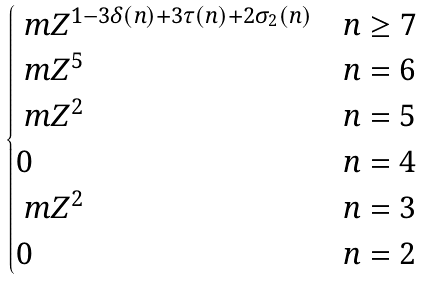<formula> <loc_0><loc_0><loc_500><loc_500>\begin{cases} \ m Z ^ { 1 - 3 \delta ( n ) + 3 \tau ( n ) + 2 \sigma _ { 2 } ( n ) } & n \geq 7 \\ \ m Z ^ { 5 } & n = 6 \\ \ m Z ^ { 2 } & n = 5 \\ 0 & n = 4 \\ \ m Z ^ { 2 } & n = 3 \\ 0 & n = 2 \\ \end{cases}</formula> 